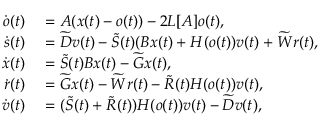<formula> <loc_0><loc_0><loc_500><loc_500>\begin{array} { r l } { \dot { o } ( t ) } & = A ( x ( t ) - o ( t ) ) - 2 L [ A ] o ( t ) , } \\ { \dot { s } ( t ) } & = \widetilde { D } v ( t ) - \widetilde { S } ( t ) ( B x ( t ) + H ( o ( t ) ) v ( t ) + \widetilde { W } r ( t ) , } \\ { \dot { x } ( t ) } & = \widetilde { S } ( t ) B x ( t ) - \widetilde { G } x ( t ) , } \\ { \dot { r } ( t ) } & = \widetilde { G } x ( t ) - \widetilde { W } r ( t ) - \widetilde { R } ( t ) H ( o ( t ) ) v ( t ) , } \\ { \dot { v } ( t ) } & = ( \widetilde { S } ( t ) + \widetilde { R } ( t ) ) H ( o ( t ) ) v ( t ) - \widetilde { D } v ( t ) , } \end{array}</formula> 